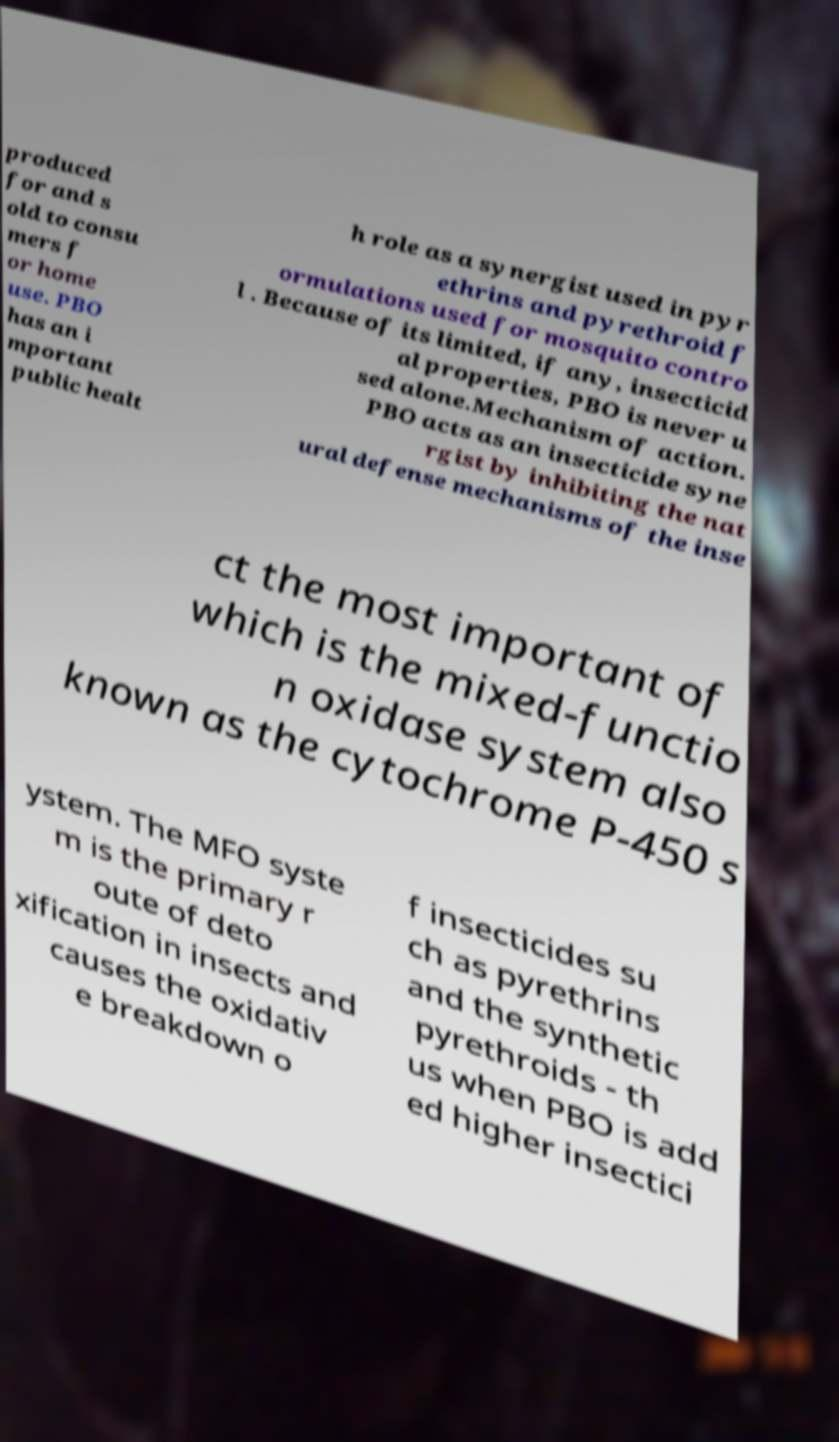Please identify and transcribe the text found in this image. produced for and s old to consu mers f or home use. PBO has an i mportant public healt h role as a synergist used in pyr ethrins and pyrethroid f ormulations used for mosquito contro l . Because of its limited, if any, insecticid al properties, PBO is never u sed alone.Mechanism of action. PBO acts as an insecticide syne rgist by inhibiting the nat ural defense mechanisms of the inse ct the most important of which is the mixed-functio n oxidase system also known as the cytochrome P-450 s ystem. The MFO syste m is the primary r oute of deto xification in insects and causes the oxidativ e breakdown o f insecticides su ch as pyrethrins and the synthetic pyrethroids - th us when PBO is add ed higher insectici 